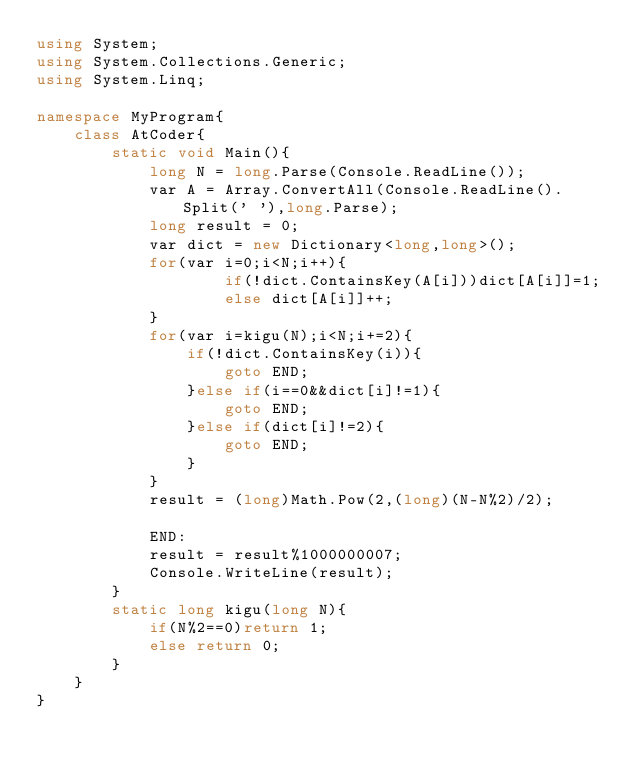<code> <loc_0><loc_0><loc_500><loc_500><_C#_>using System;
using System.Collections.Generic;
using System.Linq;

namespace MyProgram{
    class AtCoder{
        static void Main(){
            long N = long.Parse(Console.ReadLine());
            var A = Array.ConvertAll(Console.ReadLine().Split(' '),long.Parse);
            long result = 0;
            var dict = new Dictionary<long,long>();
            for(var i=0;i<N;i++){
                    if(!dict.ContainsKey(A[i]))dict[A[i]]=1;
                    else dict[A[i]]++;
            }
            for(var i=kigu(N);i<N;i+=2){
                if(!dict.ContainsKey(i)){
                    goto END;
                }else if(i==0&&dict[i]!=1){
                    goto END;
                }else if(dict[i]!=2){
                    goto END;
                }
            }
            result = (long)Math.Pow(2,(long)(N-N%2)/2);

            END:
            result = result%1000000007;
            Console.WriteLine(result);
        }
        static long kigu(long N){
            if(N%2==0)return 1;
            else return 0;
        }
    } 
}</code> 